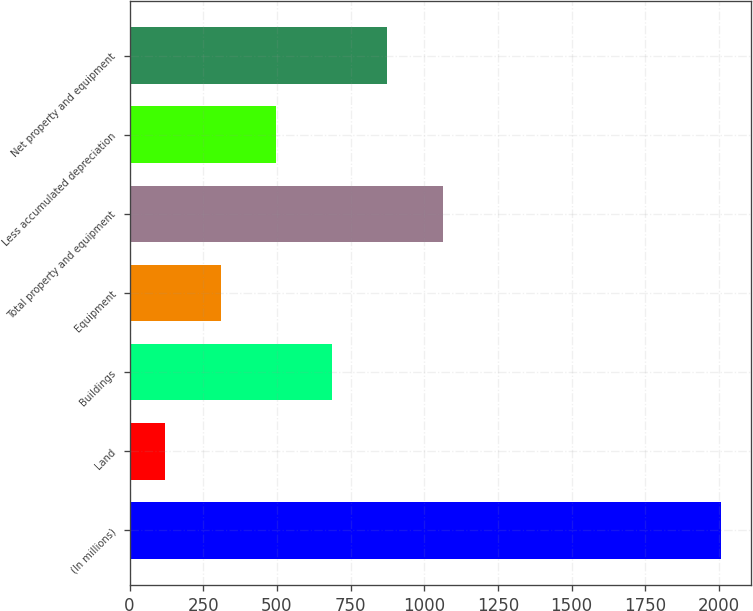<chart> <loc_0><loc_0><loc_500><loc_500><bar_chart><fcel>(In millions)<fcel>Land<fcel>Buildings<fcel>Equipment<fcel>Total property and equipment<fcel>Less accumulated depreciation<fcel>Net property and equipment<nl><fcel>2007<fcel>120<fcel>686.1<fcel>308.7<fcel>1063.5<fcel>497.4<fcel>874.8<nl></chart> 